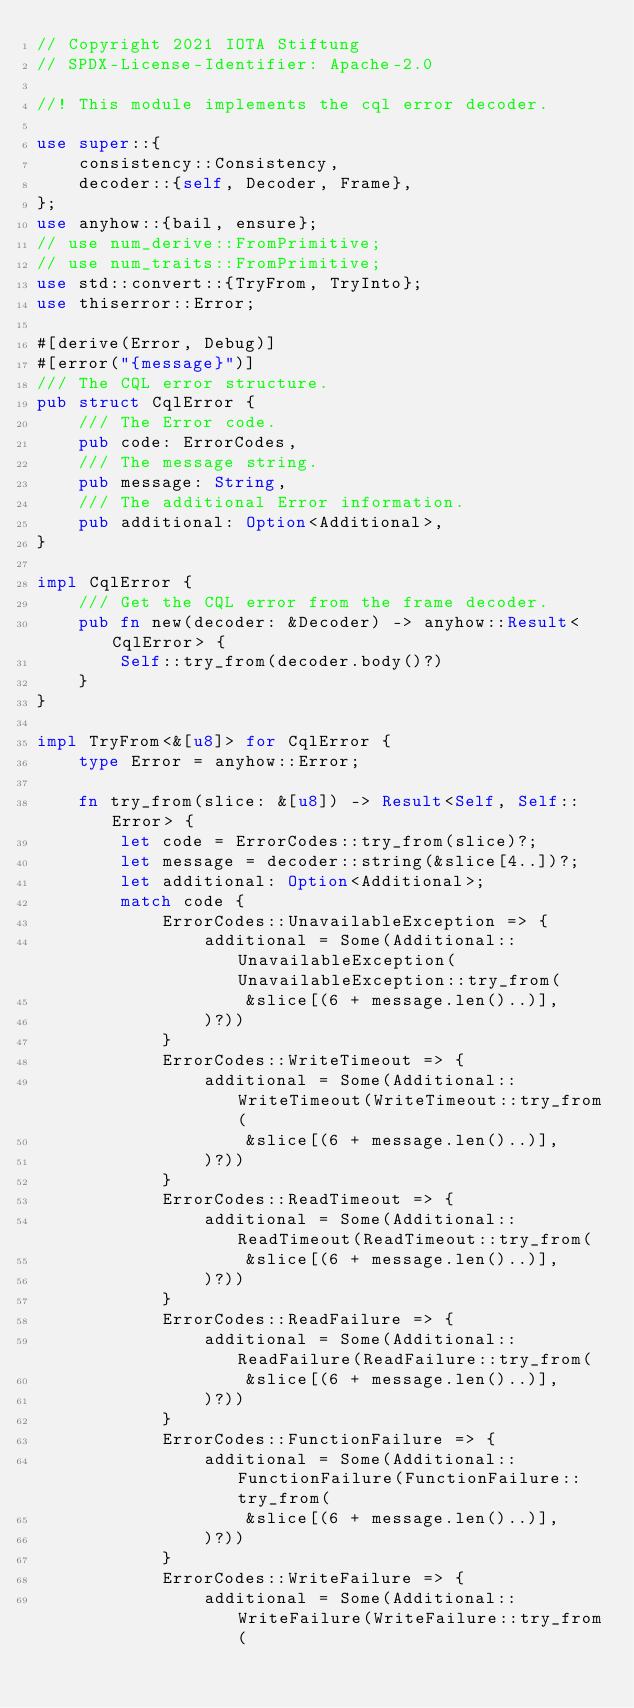Convert code to text. <code><loc_0><loc_0><loc_500><loc_500><_Rust_>// Copyright 2021 IOTA Stiftung
// SPDX-License-Identifier: Apache-2.0

//! This module implements the cql error decoder.

use super::{
    consistency::Consistency,
    decoder::{self, Decoder, Frame},
};
use anyhow::{bail, ensure};
// use num_derive::FromPrimitive;
// use num_traits::FromPrimitive;
use std::convert::{TryFrom, TryInto};
use thiserror::Error;

#[derive(Error, Debug)]
#[error("{message}")]
/// The CQL error structure.
pub struct CqlError {
    /// The Error code.
    pub code: ErrorCodes,
    /// The message string.
    pub message: String,
    /// The additional Error information.
    pub additional: Option<Additional>,
}

impl CqlError {
    /// Get the CQL error from the frame decoder.
    pub fn new(decoder: &Decoder) -> anyhow::Result<CqlError> {
        Self::try_from(decoder.body()?)
    }
}

impl TryFrom<&[u8]> for CqlError {
    type Error = anyhow::Error;

    fn try_from(slice: &[u8]) -> Result<Self, Self::Error> {
        let code = ErrorCodes::try_from(slice)?;
        let message = decoder::string(&slice[4..])?;
        let additional: Option<Additional>;
        match code {
            ErrorCodes::UnavailableException => {
                additional = Some(Additional::UnavailableException(UnavailableException::try_from(
                    &slice[(6 + message.len()..)],
                )?))
            }
            ErrorCodes::WriteTimeout => {
                additional = Some(Additional::WriteTimeout(WriteTimeout::try_from(
                    &slice[(6 + message.len()..)],
                )?))
            }
            ErrorCodes::ReadTimeout => {
                additional = Some(Additional::ReadTimeout(ReadTimeout::try_from(
                    &slice[(6 + message.len()..)],
                )?))
            }
            ErrorCodes::ReadFailure => {
                additional = Some(Additional::ReadFailure(ReadFailure::try_from(
                    &slice[(6 + message.len()..)],
                )?))
            }
            ErrorCodes::FunctionFailure => {
                additional = Some(Additional::FunctionFailure(FunctionFailure::try_from(
                    &slice[(6 + message.len()..)],
                )?))
            }
            ErrorCodes::WriteFailure => {
                additional = Some(Additional::WriteFailure(WriteFailure::try_from(</code> 